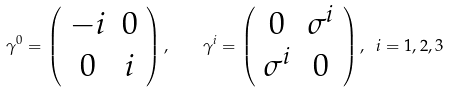<formula> <loc_0><loc_0><loc_500><loc_500>\gamma ^ { 0 } = \left ( \begin{array} { c c } - i & 0 \\ 0 & i \end{array} \right ) , \quad \gamma ^ { i } = \left ( \begin{array} { c c } 0 & \sigma ^ { i } \\ \sigma ^ { i } & 0 \end{array} \right ) , \ i = 1 , 2 , 3</formula> 